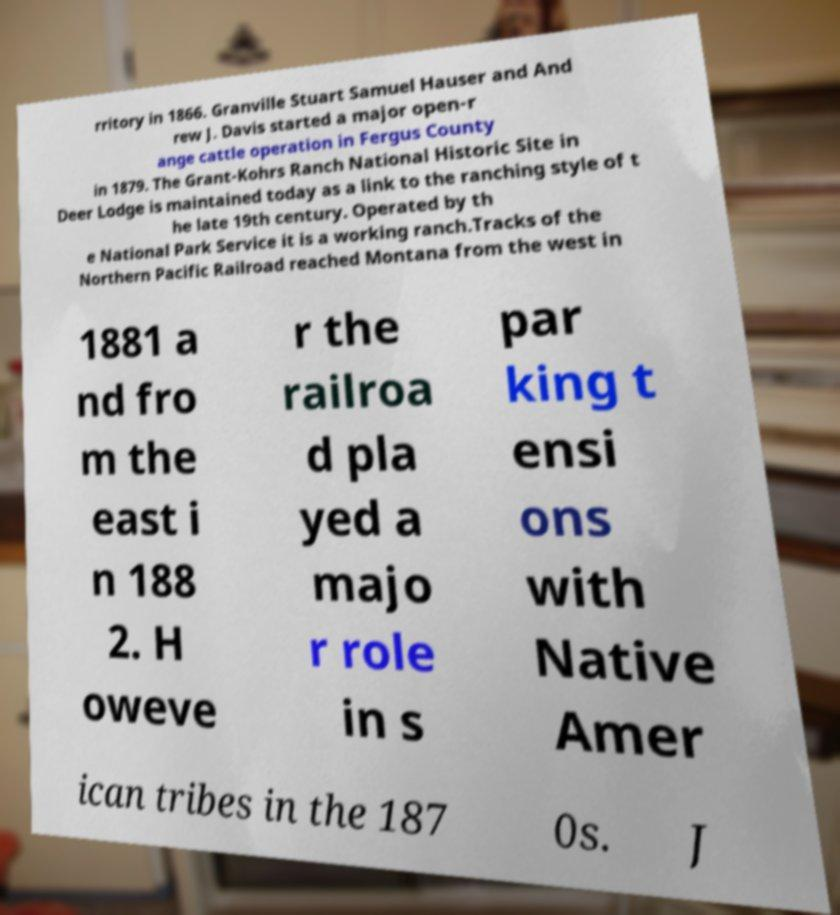I need the written content from this picture converted into text. Can you do that? rritory in 1866. Granville Stuart Samuel Hauser and And rew J. Davis started a major open-r ange cattle operation in Fergus County in 1879. The Grant-Kohrs Ranch National Historic Site in Deer Lodge is maintained today as a link to the ranching style of t he late 19th century. Operated by th e National Park Service it is a working ranch.Tracks of the Northern Pacific Railroad reached Montana from the west in 1881 a nd fro m the east i n 188 2. H oweve r the railroa d pla yed a majo r role in s par king t ensi ons with Native Amer ican tribes in the 187 0s. J 